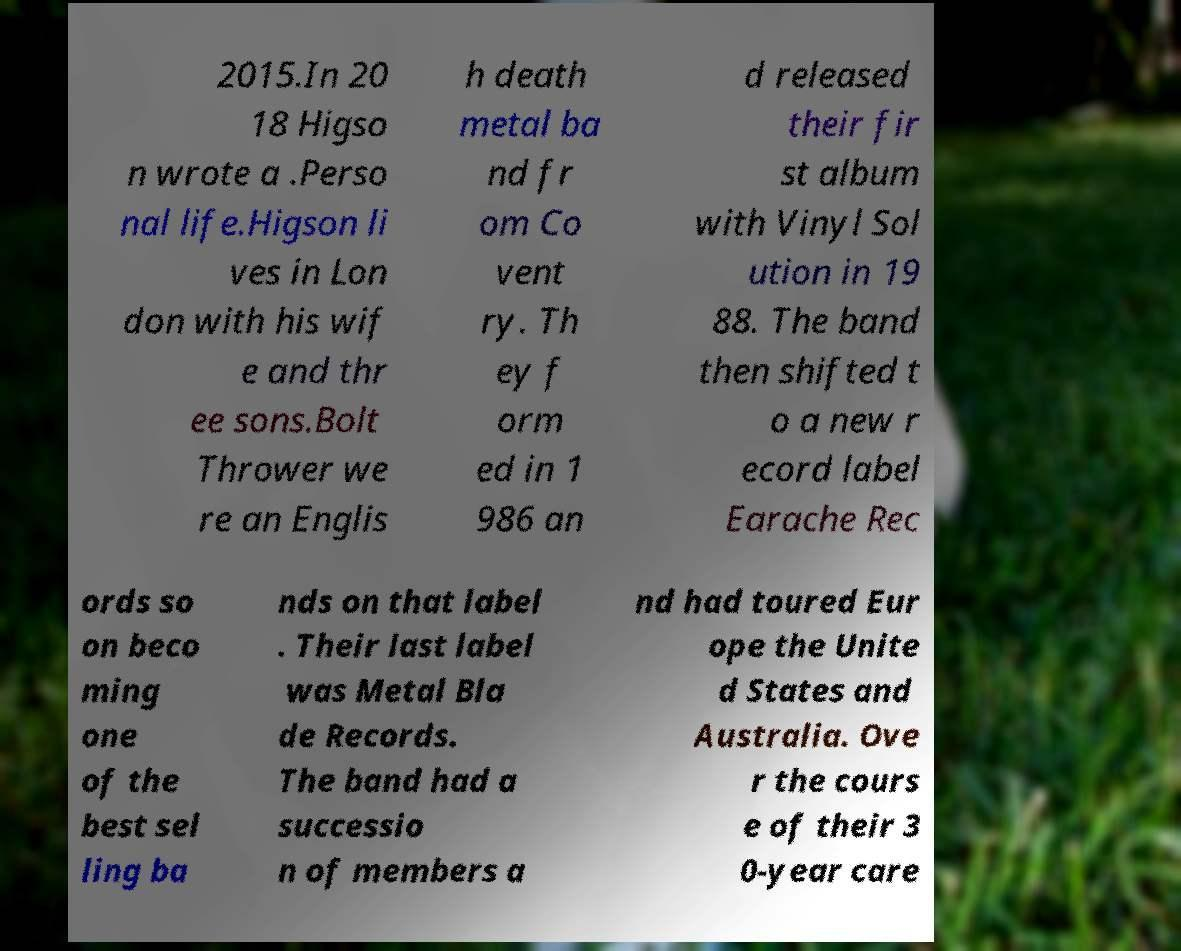Could you extract and type out the text from this image? 2015.In 20 18 Higso n wrote a .Perso nal life.Higson li ves in Lon don with his wif e and thr ee sons.Bolt Thrower we re an Englis h death metal ba nd fr om Co vent ry. Th ey f orm ed in 1 986 an d released their fir st album with Vinyl Sol ution in 19 88. The band then shifted t o a new r ecord label Earache Rec ords so on beco ming one of the best sel ling ba nds on that label . Their last label was Metal Bla de Records. The band had a successio n of members a nd had toured Eur ope the Unite d States and Australia. Ove r the cours e of their 3 0-year care 